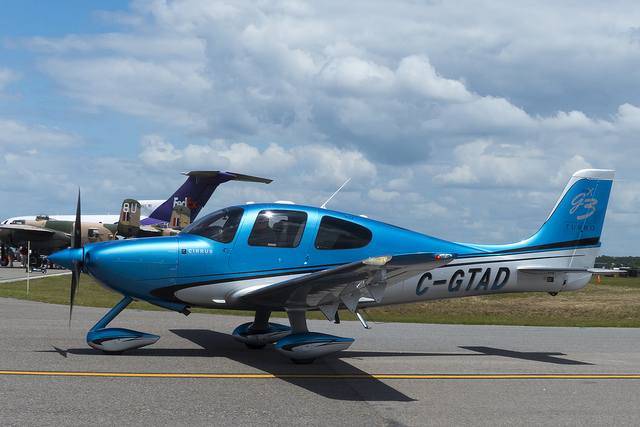Please transcribe the text information in this image. c - GTAD TURBO gz CIRRUS 8U Fed 